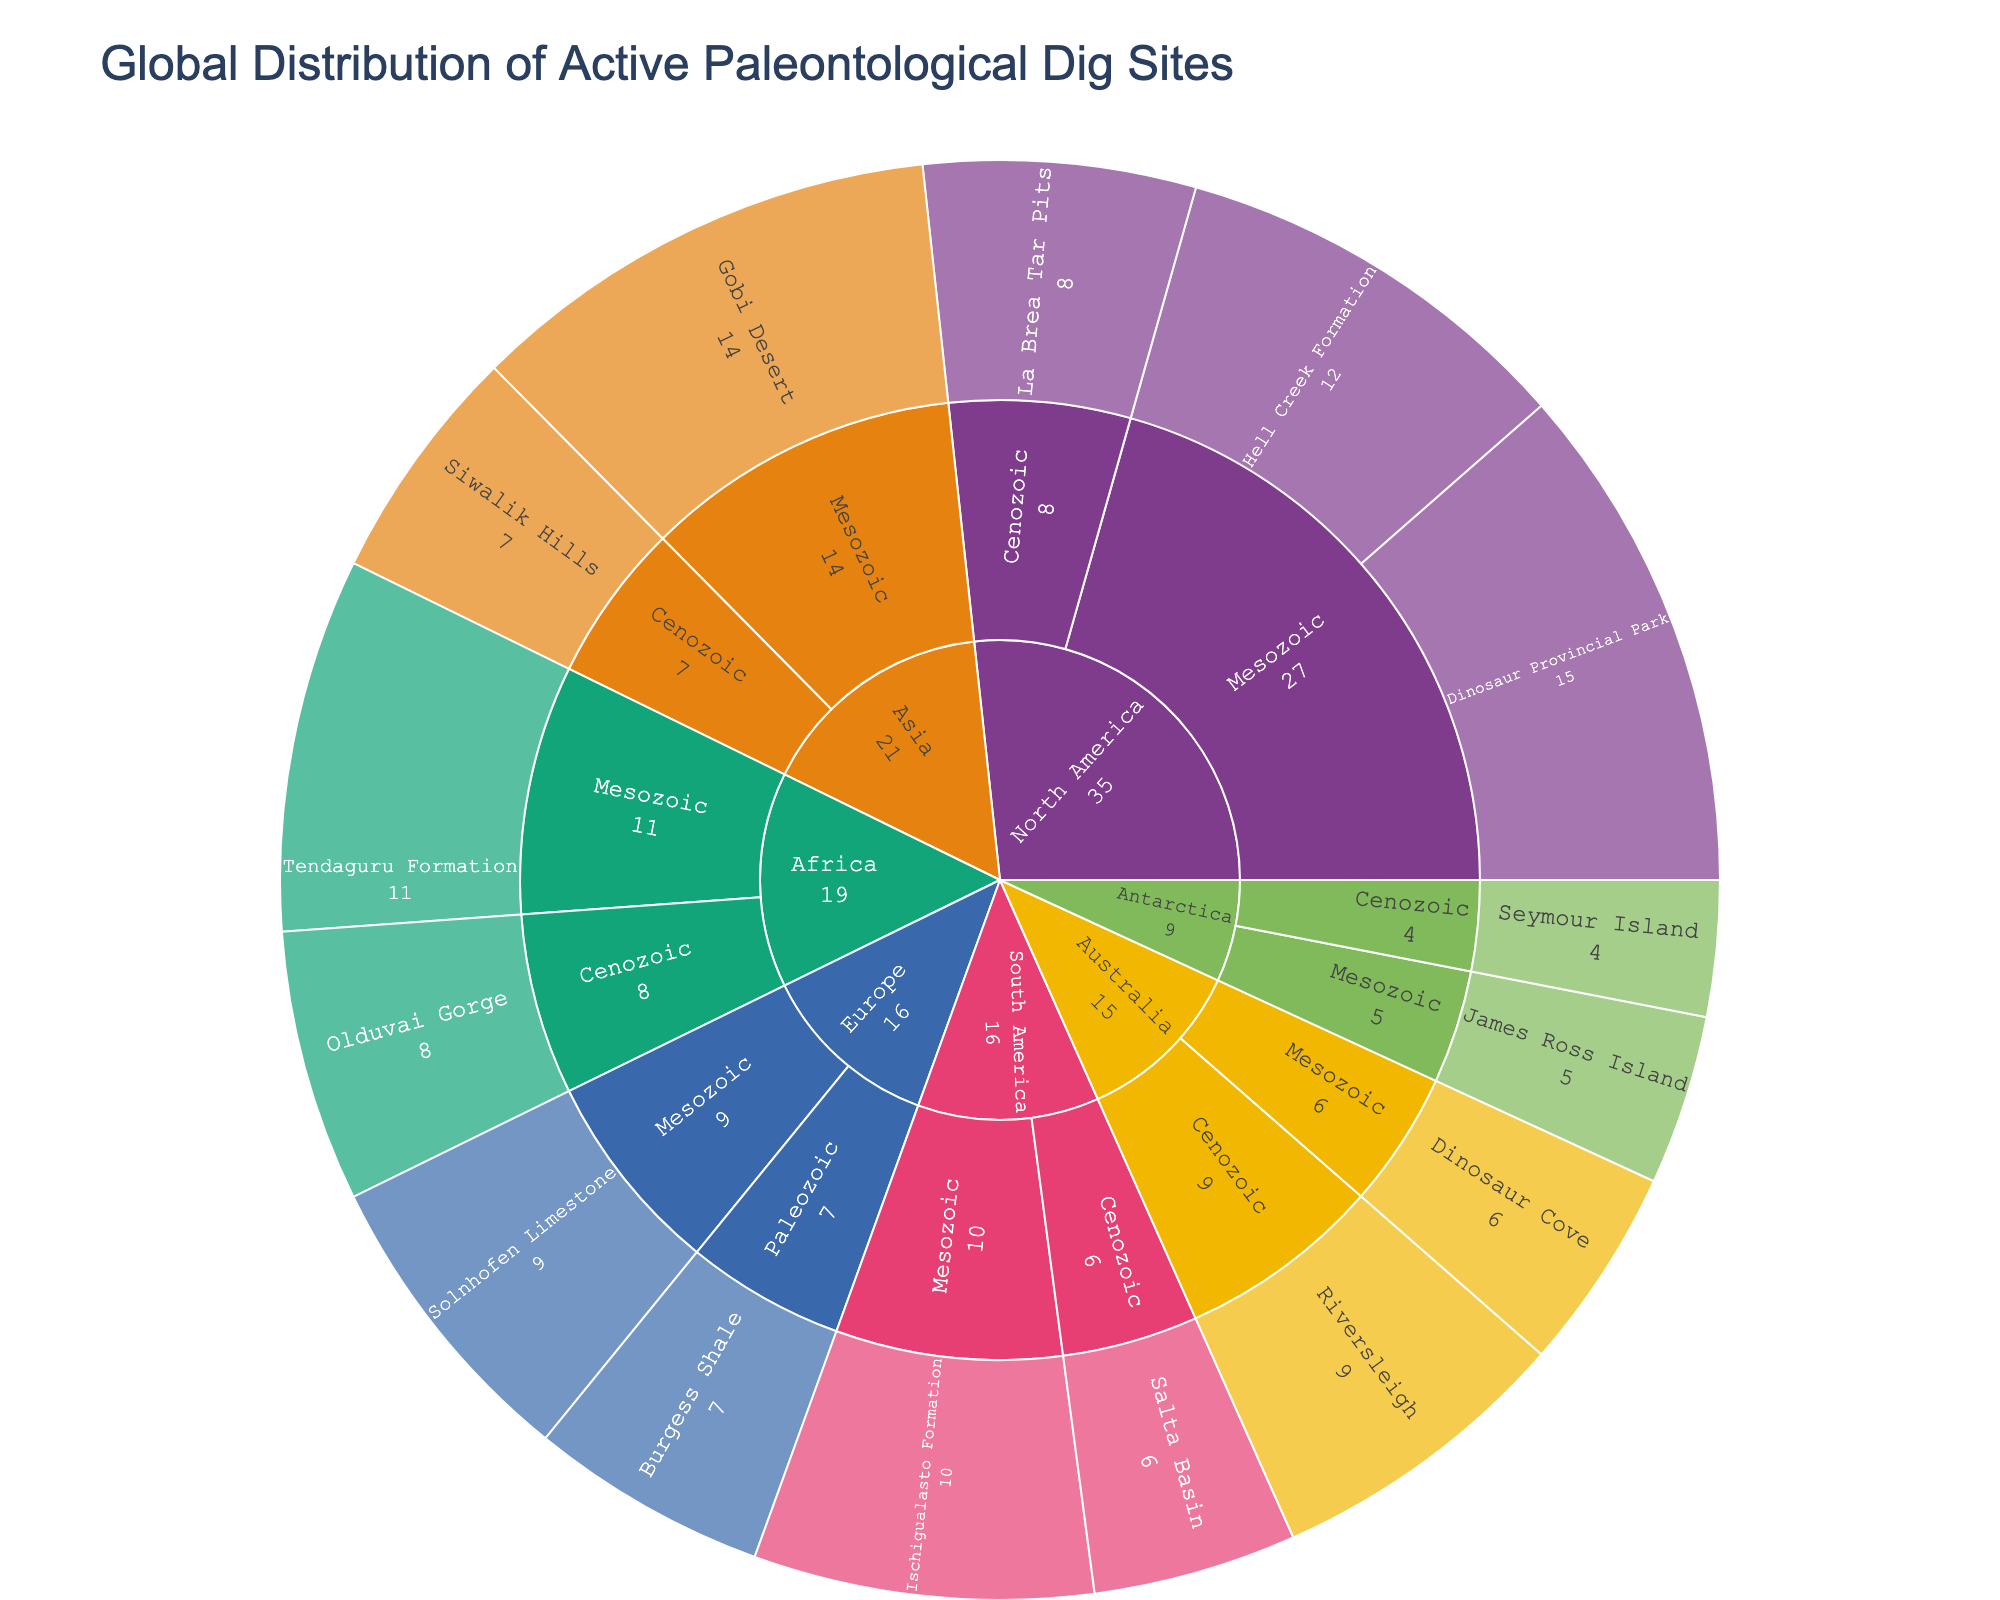How many continents are represented in the sunburst plot? The sunburst plot shows the continents as the outermost layer. By counting the unique segments at this level, we see North America, South America, Europe, Africa, Asia, Australia, and Antarctica
Answer: 7 Which continent has the highest count of active dig sites in the Mesozoic period? To find the highest count of active dig sites in the Mesozoic period, compare the counts next to the sites under the 'Mesozoic' category for each continent. North America has 15 at Dinosaur Provincial Park and 12 at Hell Creek Formation, which adds up to 27
Answer: North America What is the total number of active dig sites in the Cenozoic period? To find the total, sum the counts of all dig sites listed in the Cenozoic period. The sites are La Brea Tar Pits (8), Salta Basin (6), Olduvai Gorge (8), Siwalik Hills (7), Riversleigh (9), and Seymour Island (4). Summing these values: 8+6+8+7+9+4 = 42
Answer: 42 Which time period has more sites in Europe, Paleozoic or Mesozoic? Compare the counts of active dig sites in Europe under both time periods. Paleozoic has Burgess Shale with 7 sites and Mesozoic has Solnhofen Limestone with 9 sites. Since 9 > 7, Mesozoic has more
Answer: Mesozoic What is the average number of active dig sites per continent? To calculate the average, sum all the counts and divide by the number of continents. The total is 15+12+8+10+6+9+7+11+8+14+7+6+9+5+4 = 131. There are 7 continents, so the average is 131 / 7 ≈ 18.71
Answer: 18.71 Which site in Asia during the Mesozoic period has more active dig sites, Gobi Desert or Siwalik Hills? Compare the counts of Gobi Desert and Siwalik Hills under the Mesozoic period in Asia. Gobi Desert has 14 sites and Siwalik Hills has 7. Since 14 > 7, Gobi Desert has more
Answer: Gobi Desert Is there any continent where the count of Cenozoic sites is higher than Mesozoic sites? Compare the counts of Cenozoic and Mesozoic sites for each continent. North America (Mesozoic: 27, Cenozoic: 8), South America (Mesozoic: 10, Cenozoic: 6), Europe (Mesozoic: 9, Paleozoic: 7), Africa (Mesozoic: 11, Cenozoic: 8), Asia (Mesozoic: 14, Cenozoic: 7), Australia (Mesozoic: 6, Cenozoic: 9), Antarctica (Mesozoic: 5, Cenozoic: 4). Only Australia has higher Cenozoic sites
Answer: Australia What is the combined count of dig sites for North America and South America in all periods? Add the counts for North America and South America: (North America: 15+12+8) + (South America: 10+6) = 35 + 16 = 51
Answer: 51 Which site in North America has the least number of active dig sites? Look at the counts for the sites in North America: Dinosaur Provincial Park (15), Hell Creek Formation (12), La Brea Tar Pits (8). La Brea Tar Pits has the lowest count
Answer: La Brea Tar Pits How many dig sites are listed in the Mesozoic period? Sum the counts of all sites listed under the Mesozoic period: Dinosaur Provincial Park (15), Hell Creek Formation (12), Ischigualasto Formation (10), Solnhofen Limestone (9), Tendaguru Formation (11), Gobi Desert (14), Dinosaur Cove (6), James Ross Island (5). Total is 15+12+10+9+11+14+6+5 = 82
Answer: 82 